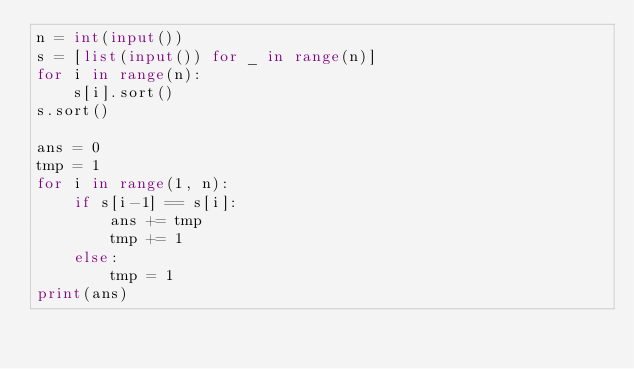Convert code to text. <code><loc_0><loc_0><loc_500><loc_500><_Python_>n = int(input())
s = [list(input()) for _ in range(n)]
for i in range(n):
    s[i].sort()
s.sort()

ans = 0
tmp = 1
for i in range(1, n):
    if s[i-1] == s[i]:
        ans += tmp
        tmp += 1
    else:
        tmp = 1
print(ans)</code> 